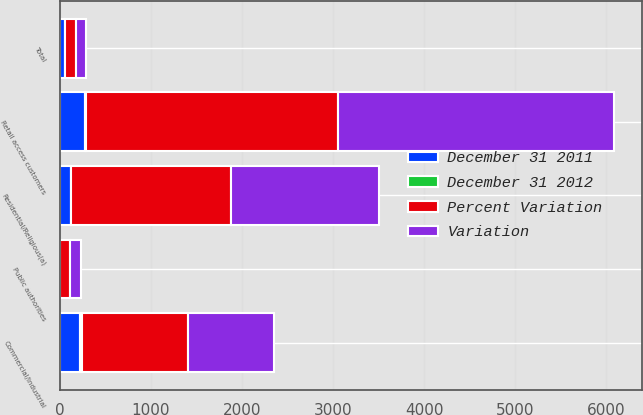Convert chart. <chart><loc_0><loc_0><loc_500><loc_500><stacked_bar_chart><ecel><fcel>Residential/Religious(a)<fcel>Commercial/Industrial<fcel>Retail access customers<fcel>Public authorities<fcel>Total<nl><fcel>Variation<fcel>1632<fcel>945<fcel>3040<fcel>114<fcel>116<nl><fcel>Percent Variation<fcel>1750<fcel>1168<fcel>2760<fcel>111<fcel>116<nl><fcel>December 31 2011<fcel>118<fcel>223<fcel>280<fcel>3<fcel>58<nl><fcel>December 31 2012<fcel>6.7<fcel>19.1<fcel>10.1<fcel>2.7<fcel>1<nl></chart> 